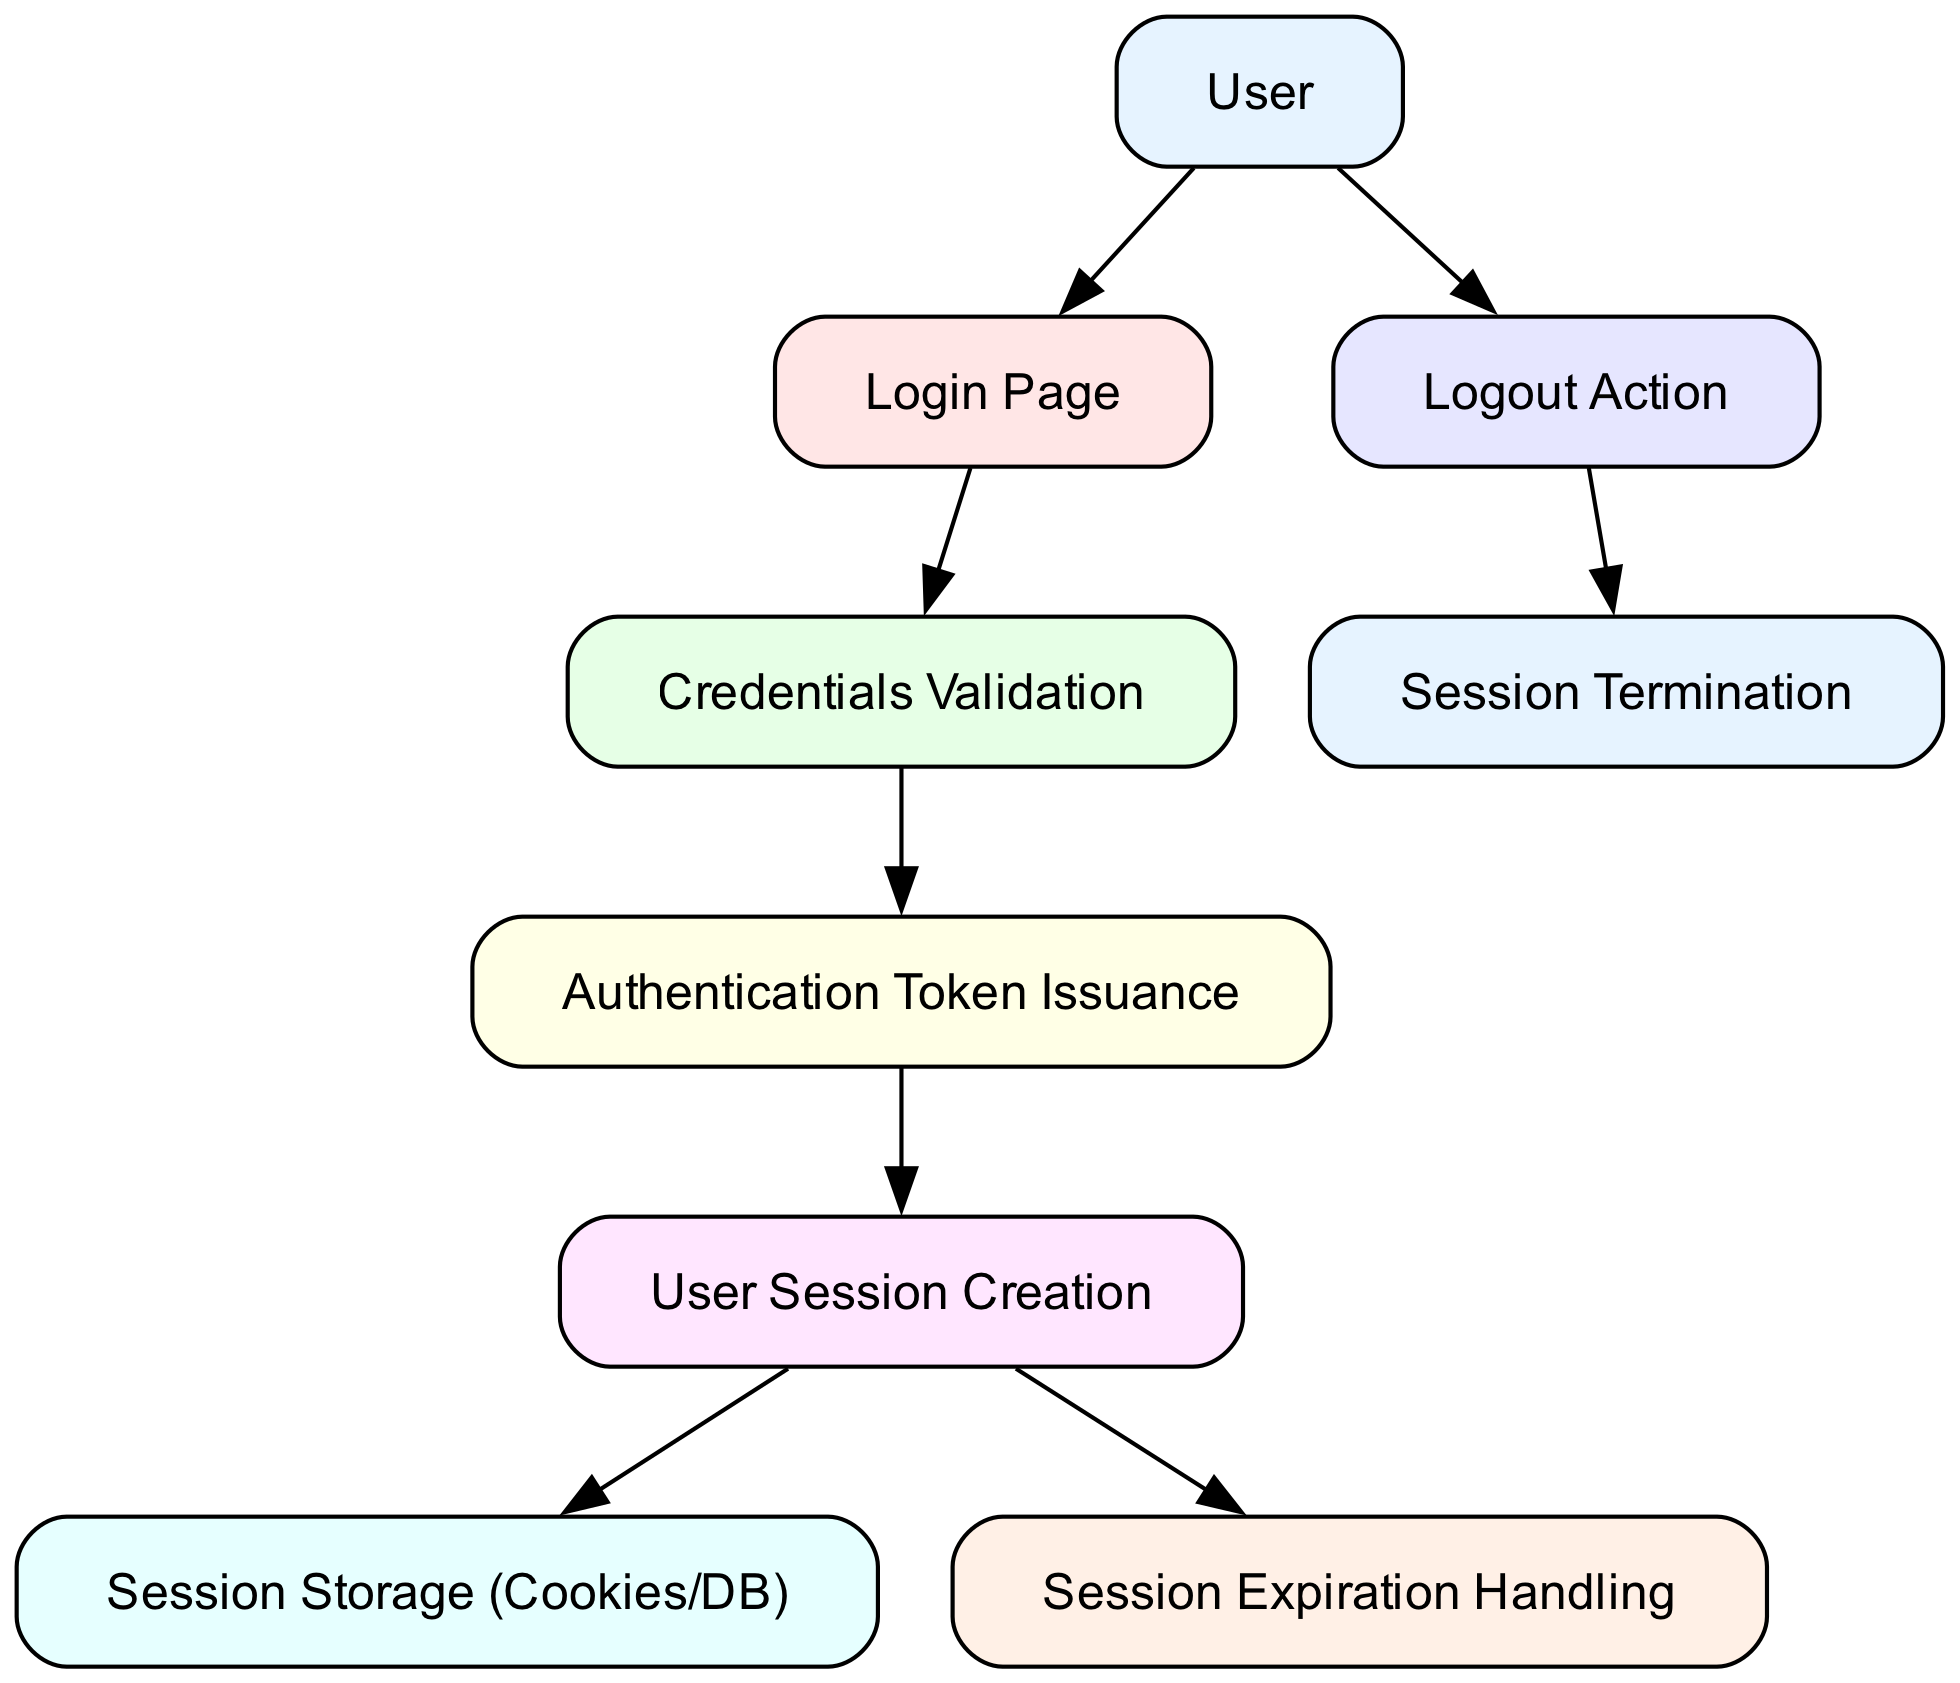What is the starting point in the authentication flow? The starting point is where the user initiates the authentication process, which is represented by the node labeled "User."
Answer: User How many nodes are in the diagram? To determine the number of nodes, we can count the items listed in the "nodes" section of the data. There are eight nodes.
Answer: 8 Which node follows "Login Page"? The node that follows "Login Page" is connected to it by an edge in the diagram. The edge indicates that after visiting the "Login Page," the next step is "Credentials Validation."
Answer: Credentials Validation What action does the "Logout Action" node lead to? After the "Logout Action," the session is terminated, meaning the flow moves to the "Session Termination" node.
Answer: Session Termination From which node does the "User Session Creation" node receive input? The "User Session Creation" node gets its input from the previous node, which is "Authentication Token Issuance." This connection shows how the authentication token is used to create a user session.
Answer: Authentication Token Issuance What happens if the user wants to log out? If the user wants to log out, they would trigger the "Logout Action," which is the initial step in the logout process.
Answer: Logout Action What aspect of the user session is handled after session creation? After the user session is created, it is important to manage how that session is stored, which is indicated by the "Session Storage."
Answer: Session Storage How many edges are shown in the diagram? The number of edges can be determined by counting the connections between nodes in the "edges" section of the data. There are eight edges.
Answer: 8 What does the "Session Expiration Handling" node indicate? This node indicates a process related to managing when user sessions expire, following the creation of the user session.
Answer: Session Expiration Handling 